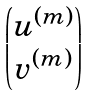<formula> <loc_0><loc_0><loc_500><loc_500>\begin{pmatrix} { u } ^ { ( m ) } \\ { v } ^ { ( m ) } \end{pmatrix}</formula> 